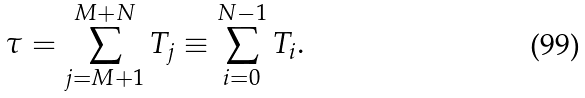Convert formula to latex. <formula><loc_0><loc_0><loc_500><loc_500>\tau = \sum _ { j = M + 1 } ^ { M + N } T _ { j } \equiv \sum _ { i = 0 } ^ { N - 1 } T _ { i } .</formula> 